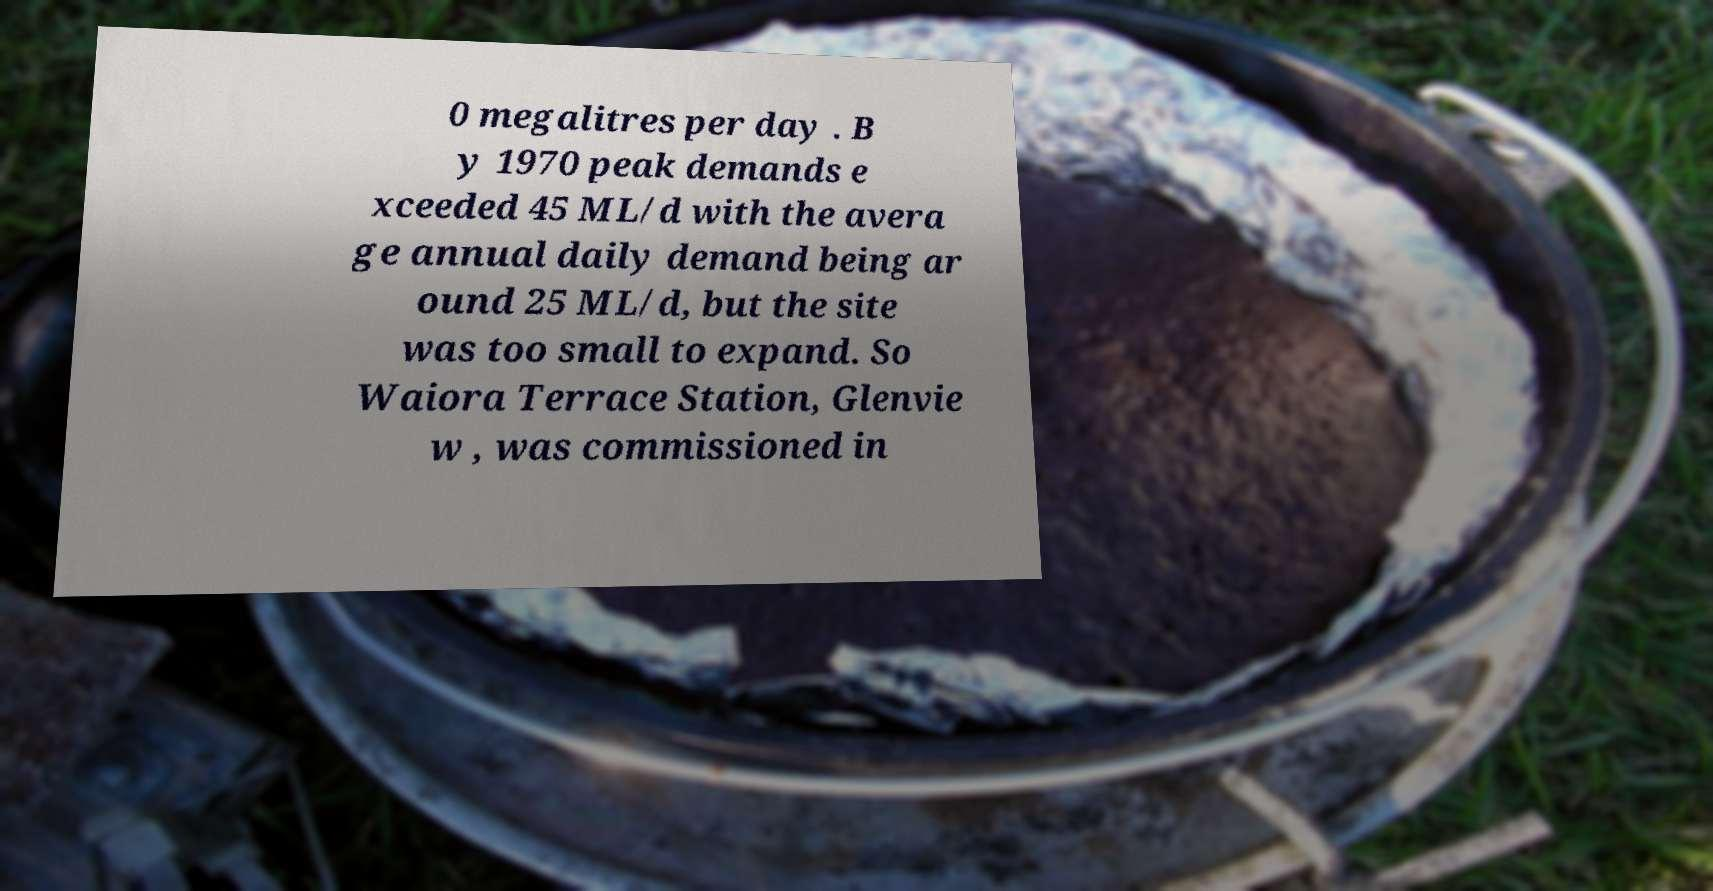I need the written content from this picture converted into text. Can you do that? 0 megalitres per day . B y 1970 peak demands e xceeded 45 ML/d with the avera ge annual daily demand being ar ound 25 ML/d, but the site was too small to expand. So Waiora Terrace Station, Glenvie w , was commissioned in 